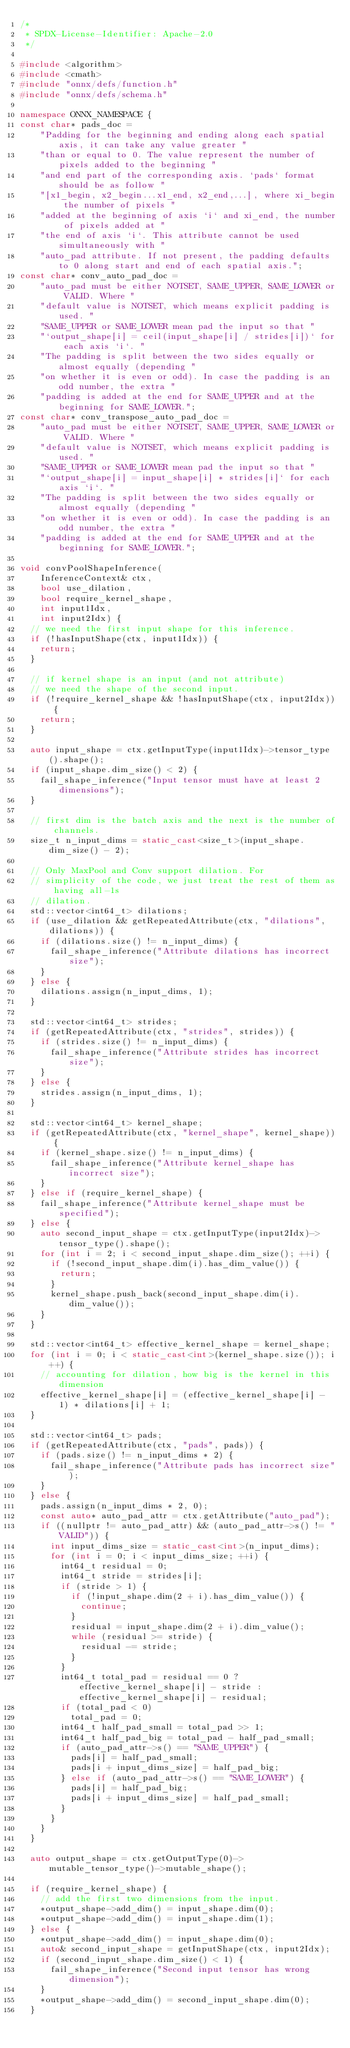<code> <loc_0><loc_0><loc_500><loc_500><_C++_>/*
 * SPDX-License-Identifier: Apache-2.0
 */

#include <algorithm>
#include <cmath>
#include "onnx/defs/function.h"
#include "onnx/defs/schema.h"

namespace ONNX_NAMESPACE {
const char* pads_doc =
    "Padding for the beginning and ending along each spatial axis, it can take any value greater "
    "than or equal to 0. The value represent the number of pixels added to the beginning "
    "and end part of the corresponding axis. `pads` format should be as follow "
    "[x1_begin, x2_begin...x1_end, x2_end,...], where xi_begin the number of pixels "
    "added at the beginning of axis `i` and xi_end, the number of pixels added at "
    "the end of axis `i`. This attribute cannot be used simultaneously with "
    "auto_pad attribute. If not present, the padding defaults to 0 along start and end of each spatial axis.";
const char* conv_auto_pad_doc =
    "auto_pad must be either NOTSET, SAME_UPPER, SAME_LOWER or VALID. Where "
    "default value is NOTSET, which means explicit padding is used. "
    "SAME_UPPER or SAME_LOWER mean pad the input so that "
    "`output_shape[i] = ceil(input_shape[i] / strides[i])` for each axis `i`. "
    "The padding is split between the two sides equally or almost equally (depending "
    "on whether it is even or odd). In case the padding is an odd number, the extra "
    "padding is added at the end for SAME_UPPER and at the beginning for SAME_LOWER.";
const char* conv_transpose_auto_pad_doc =
    "auto_pad must be either NOTSET, SAME_UPPER, SAME_LOWER or VALID. Where "
    "default value is NOTSET, which means explicit padding is used. "
    "SAME_UPPER or SAME_LOWER mean pad the input so that "
    "`output_shape[i] = input_shape[i] * strides[i]` for each axis `i`. "
    "The padding is split between the two sides equally or almost equally (depending "
    "on whether it is even or odd). In case the padding is an odd number, the extra "
    "padding is added at the end for SAME_UPPER and at the beginning for SAME_LOWER.";

void convPoolShapeInference(
    InferenceContext& ctx,
    bool use_dilation,
    bool require_kernel_shape,
    int input1Idx,
    int input2Idx) {
  // we need the first input shape for this inference.
  if (!hasInputShape(ctx, input1Idx)) {
    return;
  }

  // if kernel shape is an input (and not attribute)
  // we need the shape of the second input.
  if (!require_kernel_shape && !hasInputShape(ctx, input2Idx)) {
    return;
  }

  auto input_shape = ctx.getInputType(input1Idx)->tensor_type().shape();
  if (input_shape.dim_size() < 2) {
    fail_shape_inference("Input tensor must have at least 2 dimensions");
  }

  // first dim is the batch axis and the next is the number of channels.
  size_t n_input_dims = static_cast<size_t>(input_shape.dim_size() - 2);

  // Only MaxPool and Conv support dilation. For
  // simplicity of the code, we just treat the rest of them as having all-1s
  // dilation.
  std::vector<int64_t> dilations;
  if (use_dilation && getRepeatedAttribute(ctx, "dilations", dilations)) {
    if (dilations.size() != n_input_dims) {
      fail_shape_inference("Attribute dilations has incorrect size");
    }
  } else {
    dilations.assign(n_input_dims, 1);
  }

  std::vector<int64_t> strides;
  if (getRepeatedAttribute(ctx, "strides", strides)) {
    if (strides.size() != n_input_dims) {
      fail_shape_inference("Attribute strides has incorrect size");
    }
  } else {
    strides.assign(n_input_dims, 1);
  }

  std::vector<int64_t> kernel_shape;
  if (getRepeatedAttribute(ctx, "kernel_shape", kernel_shape)) {
    if (kernel_shape.size() != n_input_dims) {
      fail_shape_inference("Attribute kernel_shape has incorrect size");
    }
  } else if (require_kernel_shape) {
    fail_shape_inference("Attribute kernel_shape must be specified");
  } else {
    auto second_input_shape = ctx.getInputType(input2Idx)->tensor_type().shape();
    for (int i = 2; i < second_input_shape.dim_size(); ++i) {
      if (!second_input_shape.dim(i).has_dim_value()) {
        return;
      }
      kernel_shape.push_back(second_input_shape.dim(i).dim_value());
    }
  }

  std::vector<int64_t> effective_kernel_shape = kernel_shape;
  for (int i = 0; i < static_cast<int>(kernel_shape.size()); i++) {
    // accounting for dilation, how big is the kernel in this dimension
    effective_kernel_shape[i] = (effective_kernel_shape[i] - 1) * dilations[i] + 1;
  }

  std::vector<int64_t> pads;
  if (getRepeatedAttribute(ctx, "pads", pads)) {
    if (pads.size() != n_input_dims * 2) {
      fail_shape_inference("Attribute pads has incorrect size");
    }
  } else {
    pads.assign(n_input_dims * 2, 0);
    const auto* auto_pad_attr = ctx.getAttribute("auto_pad");
    if ((nullptr != auto_pad_attr) && (auto_pad_attr->s() != "VALID")) {
      int input_dims_size = static_cast<int>(n_input_dims);
      for (int i = 0; i < input_dims_size; ++i) {
        int64_t residual = 0;
        int64_t stride = strides[i];
        if (stride > 1) {
          if (!input_shape.dim(2 + i).has_dim_value()) {
            continue;
          }
          residual = input_shape.dim(2 + i).dim_value();
          while (residual >= stride) {
            residual -= stride;
          }
        }
        int64_t total_pad = residual == 0 ? effective_kernel_shape[i] - stride : effective_kernel_shape[i] - residual;
        if (total_pad < 0)
          total_pad = 0;
        int64_t half_pad_small = total_pad >> 1;
        int64_t half_pad_big = total_pad - half_pad_small;
        if (auto_pad_attr->s() == "SAME_UPPER") {
          pads[i] = half_pad_small;
          pads[i + input_dims_size] = half_pad_big;
        } else if (auto_pad_attr->s() == "SAME_LOWER") {
          pads[i] = half_pad_big;
          pads[i + input_dims_size] = half_pad_small;
        }
      }
    }
  }

  auto output_shape = ctx.getOutputType(0)->mutable_tensor_type()->mutable_shape();

  if (require_kernel_shape) {
    // add the first two dimensions from the input.
    *output_shape->add_dim() = input_shape.dim(0);
    *output_shape->add_dim() = input_shape.dim(1);
  } else {
    *output_shape->add_dim() = input_shape.dim(0);
    auto& second_input_shape = getInputShape(ctx, input2Idx);
    if (second_input_shape.dim_size() < 1) {
      fail_shape_inference("Second input tensor has wrong dimension");
    }
    *output_shape->add_dim() = second_input_shape.dim(0);
  }
</code> 